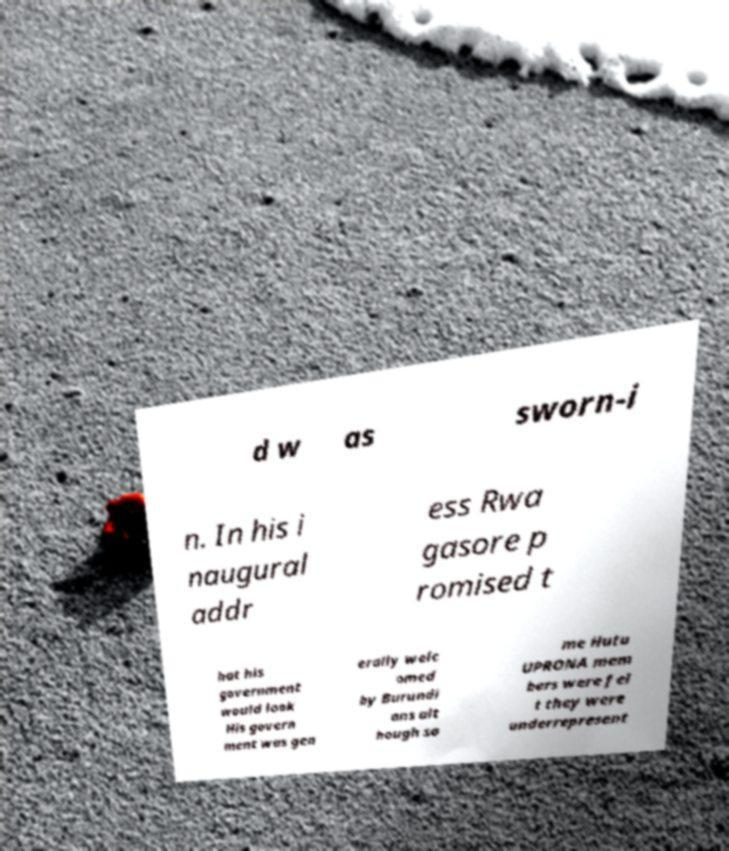Can you read and provide the text displayed in the image?This photo seems to have some interesting text. Can you extract and type it out for me? d w as sworn-i n. In his i naugural addr ess Rwa gasore p romised t hat his government would look His govern ment was gen erally welc omed by Burundi ans alt hough so me Hutu UPRONA mem bers were fel t they were underrepresent 